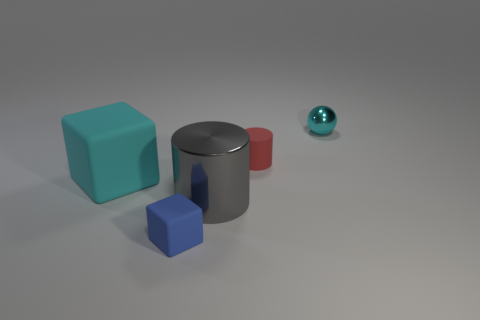Is the size of the rubber cube that is behind the gray shiny object the same as the cylinder that is on the left side of the small red matte cylinder?
Your answer should be very brief. Yes. How many other objects are the same size as the red rubber thing?
Give a very brief answer. 2. How many objects are either cyan things that are to the left of the small cylinder or big matte blocks that are on the left side of the small metallic ball?
Your response must be concise. 1. Does the ball have the same material as the cyan thing that is in front of the small cyan object?
Provide a short and direct response. No. How many other objects are there of the same shape as the big metallic object?
Offer a very short reply. 1. There is a cyan thing right of the small rubber thing in front of the small rubber cylinder that is to the right of the big gray metal thing; what is it made of?
Make the answer very short. Metal. Is the number of small red rubber objects that are left of the blue thing the same as the number of cyan metal spheres?
Ensure brevity in your answer.  No. Is the material of the cyan object behind the matte cylinder the same as the cylinder left of the red rubber cylinder?
Make the answer very short. Yes. Is there anything else that is the same material as the small cyan sphere?
Offer a terse response. Yes. Does the shiny object in front of the large cyan matte cube have the same shape as the tiny thing that is right of the red object?
Your answer should be compact. No. 